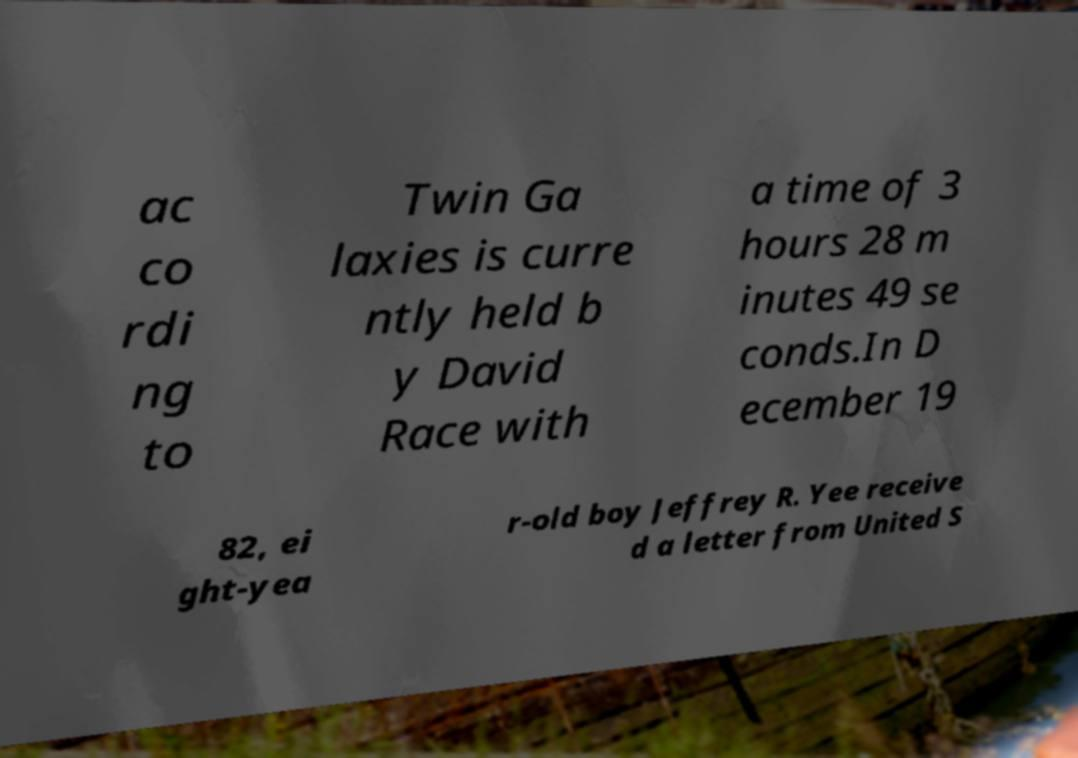I need the written content from this picture converted into text. Can you do that? ac co rdi ng to Twin Ga laxies is curre ntly held b y David Race with a time of 3 hours 28 m inutes 49 se conds.In D ecember 19 82, ei ght-yea r-old boy Jeffrey R. Yee receive d a letter from United S 